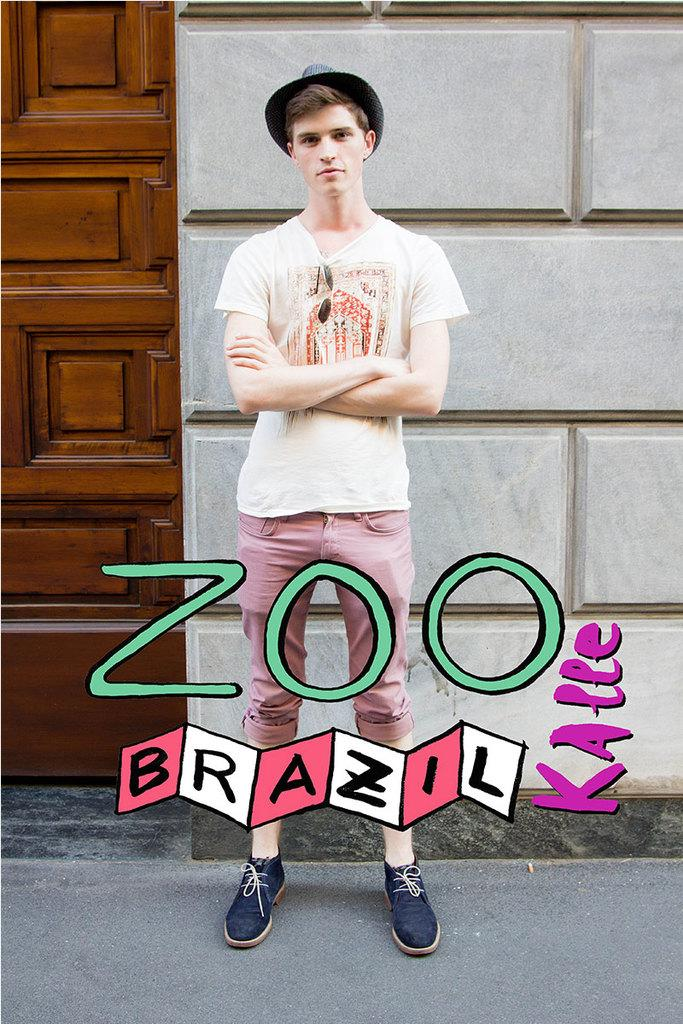Who is the main subject in the image? There is a boy in the image. What is the boy's position in relation to the building? The boy is standing in front of a building. Can you describe any other features of the building? There is a door beside the building. What type of group activity is the boy participating in with the banana in the image? There is no banana present in the image, and the boy is not participating in any group activity. 